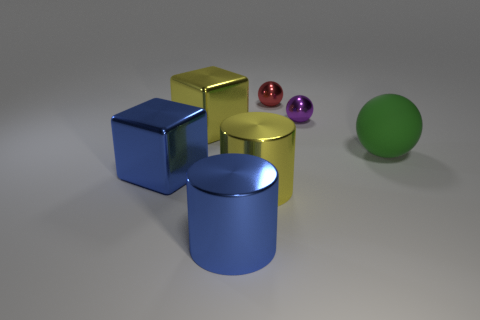How many large things are shiny spheres or rubber objects?
Give a very brief answer. 1. There is a big metallic cylinder that is in front of the big yellow metal cylinder; is it the same color as the object that is on the left side of the yellow cube?
Make the answer very short. Yes. Are there any large cubes made of the same material as the red sphere?
Keep it short and to the point. Yes. How many yellow objects are either big metal things or matte objects?
Provide a short and direct response. 2. Are there more tiny purple shiny spheres that are right of the large blue metallic cylinder than gray matte blocks?
Offer a terse response. Yes. Do the green rubber ball and the purple thing have the same size?
Offer a terse response. No. What is the color of the other large block that is the same material as the blue block?
Your answer should be compact. Yellow. Are there the same number of big blue objects behind the tiny purple metal object and large yellow objects that are right of the matte sphere?
Your answer should be very brief. Yes. What is the shape of the large metal object that is in front of the yellow metallic thing that is in front of the green matte object?
Offer a very short reply. Cylinder. What is the material of the big green thing that is the same shape as the red metal thing?
Your answer should be very brief. Rubber. 